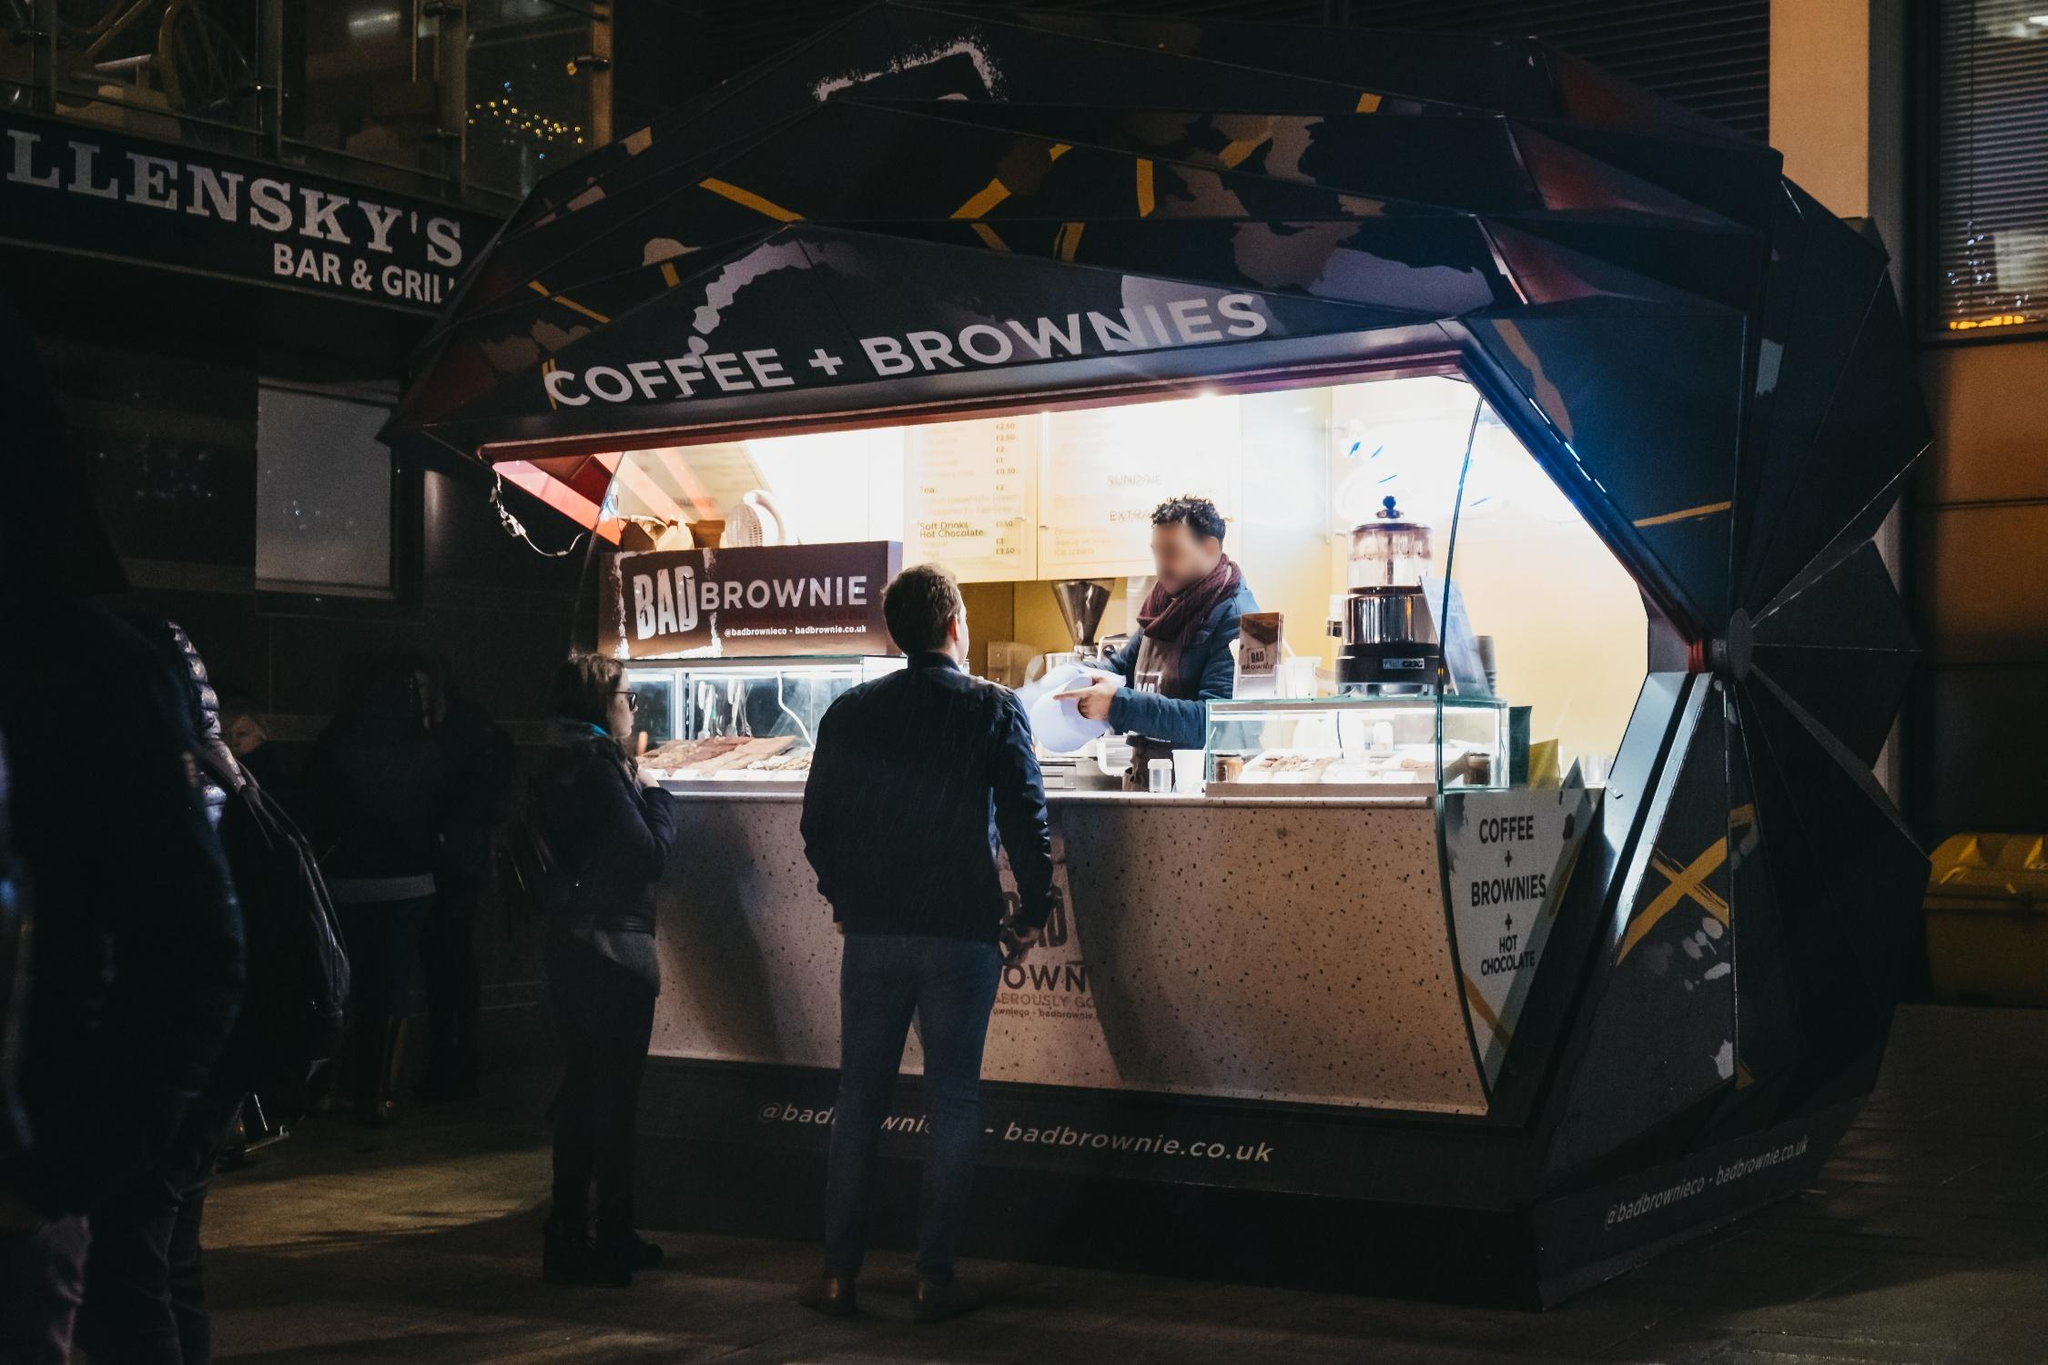What do you see happening in this image? The image vividly captures a lively scene at the 'BADBROWNIE' stand during night, bathed in warm, inviting light. A vendor, engaged in serving, interacts with a customer poised at the counter, while various onlookers gather around, intrigued by the offerings. The stand, with its unique hexagonal shape and vibrant yellow and white awning, serves as a beacon in the night, drawing in city dwellers with the promise of coffee and delectably rich brownies. The dimly lit surroundings, peppered with other establishments, contribute to a bustling urban nightlife atmosphere. This setting not only portrays a business transaction but also a slice of city life, where moments of pleasure are savored amidst the urban rush. 